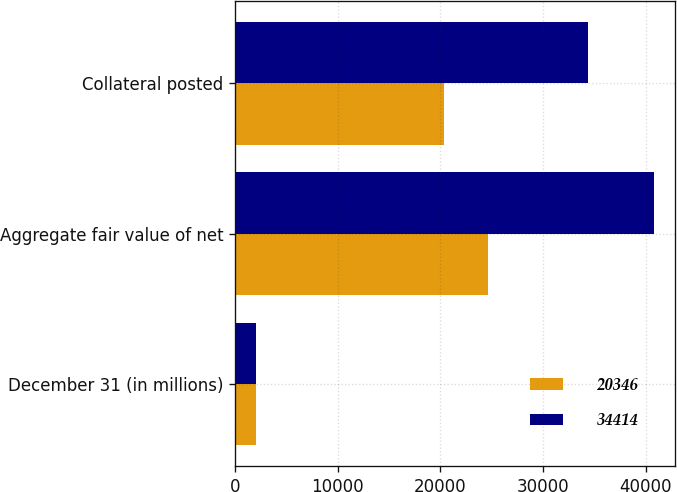Convert chart to OTSL. <chart><loc_0><loc_0><loc_500><loc_500><stacked_bar_chart><ecel><fcel>December 31 (in millions)<fcel>Aggregate fair value of net<fcel>Collateral posted<nl><fcel>20346<fcel>2013<fcel>24631<fcel>20346<nl><fcel>34414<fcel>2012<fcel>40844<fcel>34414<nl></chart> 